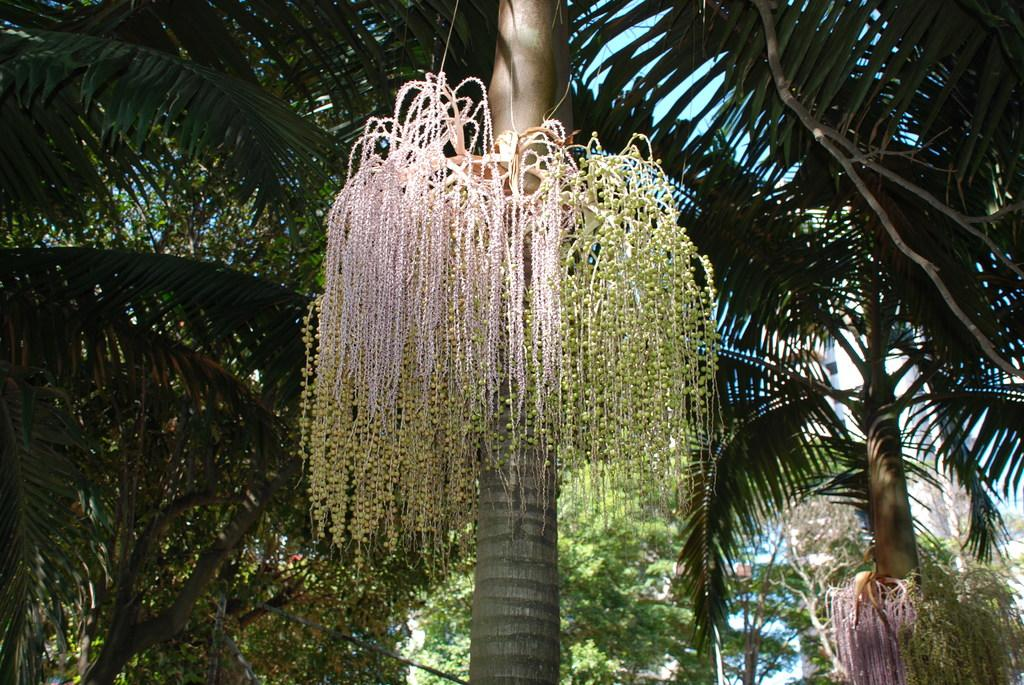What type of vegetation can be seen in the image? There are trees in the image. What part of the natural environment is visible in the image? The sky is visible in the background of the image. What type of stretch can be seen in the image? There is no stretch present in the image. What town is visible in the image? There is no town visible in the image; it only features trees and the sky. 